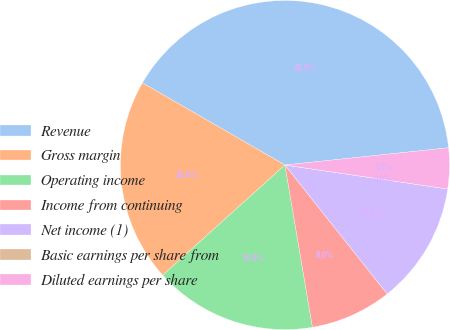<chart> <loc_0><loc_0><loc_500><loc_500><pie_chart><fcel>Revenue<fcel>Gross margin<fcel>Operating income<fcel>Income from continuing<fcel>Net income (1)<fcel>Basic earnings per share from<fcel>Diluted earnings per share<nl><fcel>40.0%<fcel>20.0%<fcel>16.0%<fcel>8.0%<fcel>12.0%<fcel>0.0%<fcel>4.0%<nl></chart> 